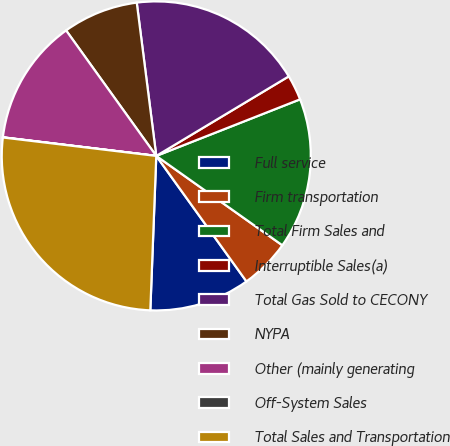Convert chart. <chart><loc_0><loc_0><loc_500><loc_500><pie_chart><fcel>Full service<fcel>Firm transportation<fcel>Total Firm Sales and<fcel>Interruptible Sales(a)<fcel>Total Gas Sold to CECONY<fcel>NYPA<fcel>Other (mainly generating<fcel>Off-System Sales<fcel>Total Sales and Transportation<nl><fcel>10.53%<fcel>5.27%<fcel>15.78%<fcel>2.64%<fcel>18.41%<fcel>7.9%<fcel>13.16%<fcel>0.02%<fcel>26.29%<nl></chart> 